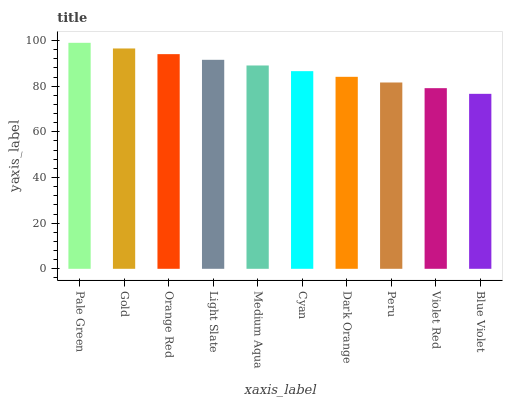Is Blue Violet the minimum?
Answer yes or no. Yes. Is Pale Green the maximum?
Answer yes or no. Yes. Is Gold the minimum?
Answer yes or no. No. Is Gold the maximum?
Answer yes or no. No. Is Pale Green greater than Gold?
Answer yes or no. Yes. Is Gold less than Pale Green?
Answer yes or no. Yes. Is Gold greater than Pale Green?
Answer yes or no. No. Is Pale Green less than Gold?
Answer yes or no. No. Is Medium Aqua the high median?
Answer yes or no. Yes. Is Cyan the low median?
Answer yes or no. Yes. Is Cyan the high median?
Answer yes or no. No. Is Blue Violet the low median?
Answer yes or no. No. 